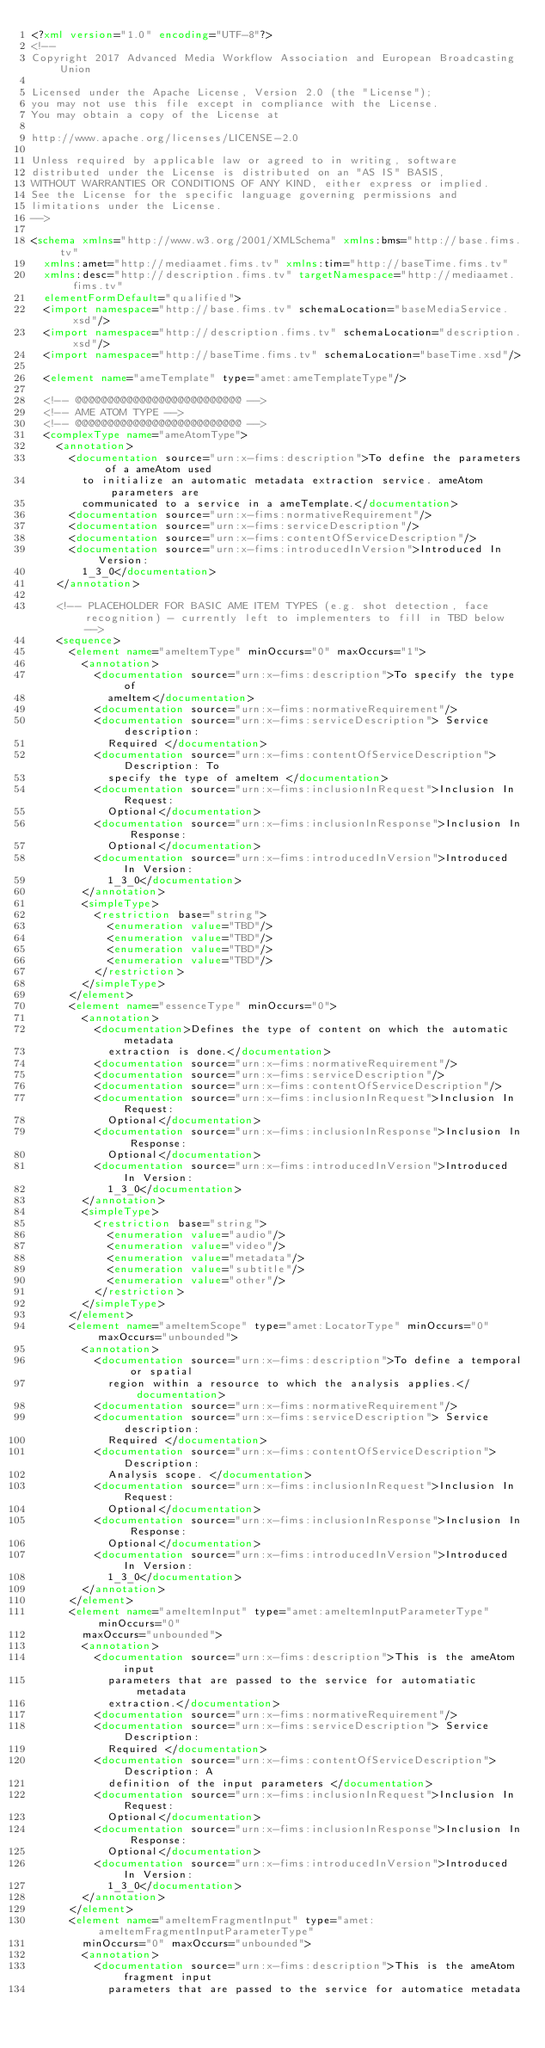Convert code to text. <code><loc_0><loc_0><loc_500><loc_500><_XML_><?xml version="1.0" encoding="UTF-8"?>
<!--
Copyright 2017 Advanced Media Workflow Association and European Broadcasting Union

Licensed under the Apache License, Version 2.0 (the "License"); 
you may not use this file except in compliance with the License. 
You may obtain a copy of the License at 

http://www.apache.org/licenses/LICENSE-2.0 

Unless required by applicable law or agreed to in writing, software 
distributed under the License is distributed on an "AS IS" BASIS, 
WITHOUT WARRANTIES OR CONDITIONS OF ANY KIND, either express or implied. 
See the License for the specific language governing permissions and 
limitations under the License.
-->

<schema xmlns="http://www.w3.org/2001/XMLSchema" xmlns:bms="http://base.fims.tv"
	xmlns:amet="http://mediaamet.fims.tv" xmlns:tim="http://baseTime.fims.tv"
	xmlns:desc="http://description.fims.tv" targetNamespace="http://mediaamet.fims.tv"
	elementFormDefault="qualified">
	<import namespace="http://base.fims.tv" schemaLocation="baseMediaService.xsd"/>
	<import namespace="http://description.fims.tv" schemaLocation="description.xsd"/>
	<import namespace="http://baseTime.fims.tv" schemaLocation="baseTime.xsd"/>

	<element name="ameTemplate" type="amet:ameTemplateType"/>

	<!-- @@@@@@@@@@@@@@@@@@@@@@@@@@ -->
	<!-- AME ATOM TYPE -->
	<!-- @@@@@@@@@@@@@@@@@@@@@@@@@@ -->
	<complexType name="ameAtomType">
		<annotation>
			<documentation source="urn:x-fims:description">To define the parameters of a ameAtom used
				to initialize an automatic metadata extraction service. ameAtom parameters are
				communicated to a service in a ameTemplate.</documentation>
			<documentation source="urn:x-fims:normativeRequirement"/>
			<documentation source="urn:x-fims:serviceDescription"/>
			<documentation source="urn:x-fims:contentOfServiceDescription"/>
			<documentation source="urn:x-fims:introducedInVersion">Introduced In Version:
				1_3_0</documentation>
		</annotation>

		<!-- PLACEHOLDER FOR BASIC AME ITEM TYPES (e.g. shot detection, face recognition) - currently left to implementers to fill in TBD below -->
		<sequence>
			<element name="ameItemType" minOccurs="0" maxOccurs="1">
				<annotation>
					<documentation source="urn:x-fims:description">To specify the type of
						ameItem</documentation>
					<documentation source="urn:x-fims:normativeRequirement"/>
					<documentation source="urn:x-fims:serviceDescription"> Service description:
						Required </documentation>
					<documentation source="urn:x-fims:contentOfServiceDescription"> Description: To
						specify the type of ameItem </documentation>
					<documentation source="urn:x-fims:inclusionInRequest">Inclusion In Request:
						Optional</documentation>
					<documentation source="urn:x-fims:inclusionInResponse">Inclusion In Response:
						Optional</documentation>
					<documentation source="urn:x-fims:introducedInVersion">Introduced In Version:
						1_3_0</documentation>
				</annotation>
				<simpleType>
					<restriction base="string">
						<enumeration value="TBD"/>
						<enumeration value="TBD"/>
						<enumeration value="TBD"/>
						<enumeration value="TBD"/>
					</restriction>
				</simpleType>
			</element>
			<element name="essenceType" minOccurs="0">
				<annotation>
					<documentation>Defines the type of content on which the automatic metadata
						extraction is done.</documentation>
					<documentation source="urn:x-fims:normativeRequirement"/>
					<documentation source="urn:x-fims:serviceDescription"/>
					<documentation source="urn:x-fims:contentOfServiceDescription"/>
					<documentation source="urn:x-fims:inclusionInRequest">Inclusion In Request:
						Optional</documentation>
					<documentation source="urn:x-fims:inclusionInResponse">Inclusion In Response:
						Optional</documentation>
					<documentation source="urn:x-fims:introducedInVersion">Introduced In Version:
						1_3_0</documentation>
				</annotation>
				<simpleType>
					<restriction base="string">
						<enumeration value="audio"/>
						<enumeration value="video"/>
						<enumeration value="metadata"/>
						<enumeration value="subtitle"/>
						<enumeration value="other"/>
					</restriction>
				</simpleType>
			</element>
			<element name="ameItemScope" type="amet:LocatorType" minOccurs="0" maxOccurs="unbounded">
				<annotation>
					<documentation source="urn:x-fims:description">To define a temporal or spatial
						region within a resource to which the analysis applies.</documentation>
					<documentation source="urn:x-fims:normativeRequirement"/>
					<documentation source="urn:x-fims:serviceDescription"> Service description:
						Required </documentation>
					<documentation source="urn:x-fims:contentOfServiceDescription"> Description:
						Analysis scope. </documentation>
					<documentation source="urn:x-fims:inclusionInRequest">Inclusion In Request:
						Optional</documentation>
					<documentation source="urn:x-fims:inclusionInResponse">Inclusion In Response:
						Optional</documentation>
					<documentation source="urn:x-fims:introducedInVersion">Introduced In Version:
						1_3_0</documentation>
				</annotation>
			</element>
			<element name="ameItemInput" type="amet:ameItemInputParameterType" minOccurs="0"
				maxOccurs="unbounded">
				<annotation>
					<documentation source="urn:x-fims:description">This is the ameAtom input
						parameters that are passed to the service for automatiatic metadata
						extraction.</documentation>
					<documentation source="urn:x-fims:normativeRequirement"/>
					<documentation source="urn:x-fims:serviceDescription"> Service Description:
						Required </documentation>
					<documentation source="urn:x-fims:contentOfServiceDescription"> Description: A
						definition of the input parameters </documentation>
					<documentation source="urn:x-fims:inclusionInRequest">Inclusion In Request:
						Optional</documentation>
					<documentation source="urn:x-fims:inclusionInResponse">Inclusion In Response:
						Optional</documentation>
					<documentation source="urn:x-fims:introducedInVersion">Introduced In Version:
						1_3_0</documentation>
				</annotation>
			</element>
			<element name="ameItemFragmentInput" type="amet:ameItemFragmentInputParameterType"
				minOccurs="0" maxOccurs="unbounded">
				<annotation>
					<documentation source="urn:x-fims:description">This is the ameAtom fragment input
						parameters that are passed to the service for automatice metadata</code> 